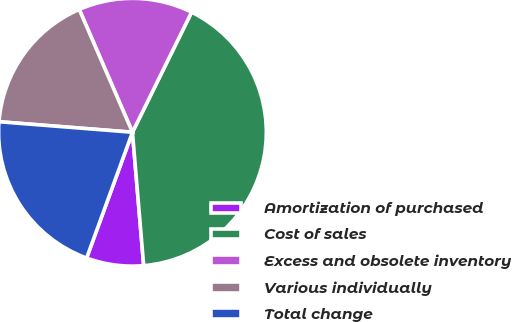<chart> <loc_0><loc_0><loc_500><loc_500><pie_chart><fcel>Amortization of purchased<fcel>Cost of sales<fcel>Excess and obsolete inventory<fcel>Various individually<fcel>Total change<nl><fcel>6.9%<fcel>41.38%<fcel>13.79%<fcel>17.24%<fcel>20.69%<nl></chart> 